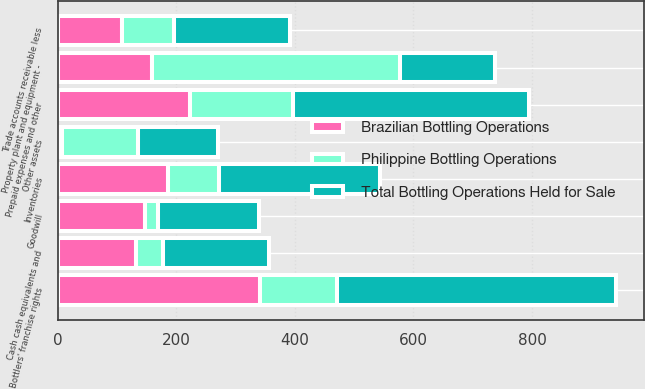<chart> <loc_0><loc_0><loc_500><loc_500><stacked_bar_chart><ecel><fcel>Cash cash equivalents and<fcel>Trade accounts receivable less<fcel>Inventories<fcel>Prepaid expenses and other<fcel>Other assets<fcel>Property plant and equipment -<fcel>Bottlers' franchise rights<fcel>Goodwill<nl><fcel>Brazilian Bottling Operations<fcel>133<fcel>108<fcel>187<fcel>223<fcel>7<fcel>159<fcel>341<fcel>148<nl><fcel>Philippine Bottling Operations<fcel>45<fcel>88<fcel>85<fcel>174<fcel>128<fcel>419<fcel>130<fcel>22<nl><fcel>Total Bottling Operations Held for Sale<fcel>178<fcel>196<fcel>272<fcel>397<fcel>135<fcel>159<fcel>471<fcel>170<nl></chart> 